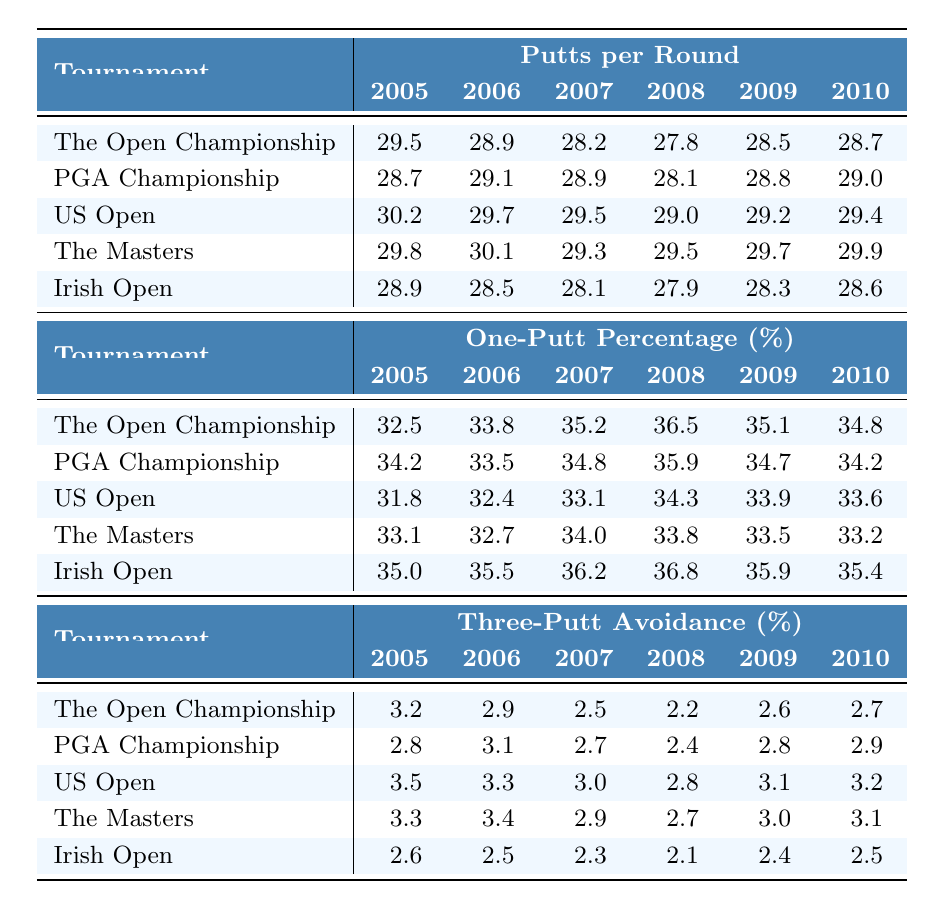What is the lowest number of putts per round that Padraig Harrington recorded in 2008? In 2008, reviewing the putts per round for each tournament, the lowest value is 27.8 from The Open Championship.
Answer: 27.8 What was Padraig Harrington's one-putt percentage during the 2005 US Open? The one-putt percentage for the 2005 US Open is 31.8%.
Answer: 31.8% In which tournament in 2006 did Harrington avoid the most three-putts? In 2006, Harrington avoided the most three-putts in the Irish Open, with a percentage of 2.5%.
Answer: 2.5% What was the difference in putts per round between the 2005 Open Championship and the 2009 PGA Championship? The 2005 putts per round for The Open Championship was 29.5, while the 2009 for the PGA Championship was 28.8. The difference is 29.5 - 28.8 = 0.7.
Answer: 0.7 Was there a year when Harrington had a one-putt percentage greater than 36% at any tournament? Yes, in 2008, Harrington had a one-putt percentage of 36.5% at The Open Championship, which is greater than 36%.
Answer: Yes What was the average number of putts per round for Harrington in the 2009 Masters and the 2010 Irish Open? The putts per round for the 2009 Masters was 29.7 and for the 2010 Irish Open was 28.6. The average is (29.7 + 28.6) / 2 = 29.15.
Answer: 29.15 Which tournament showed the highest three-putt avoidance percentage for Harrington in 2007? The highest three-putt avoidance percentage in 2007 was for the Irish Open with a percentage of 2.3%.
Answer: 2.3% Comparing Harrington's putting statistics in the 2008 Masters and Irish Open, which tournament had a higher number of putts per round? In 2008, the Masters had 29.5 putts per round, while the Irish Open had 27.9 putts per round. Hence, the Masters had a higher number of putts per round.
Answer: Masters What was the trend in putts per round for Harrington from 2005 to 2010 in the PGA Championship? The trend in putts per round for Harrington in the PGA Championship went from 28.7 in 2005 to 29.0 in 2010, showing a slight increase overall.
Answer: Slight increase 